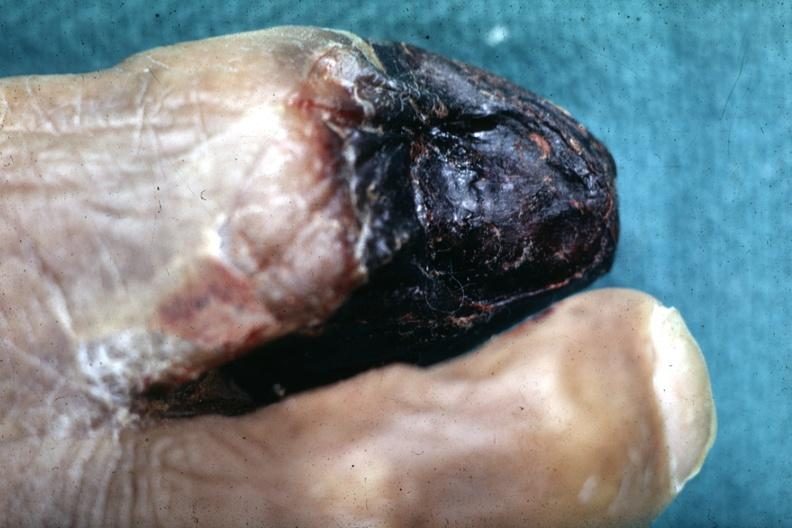re renal polycystic disease legs present?
Answer the question using a single word or phrase. No 